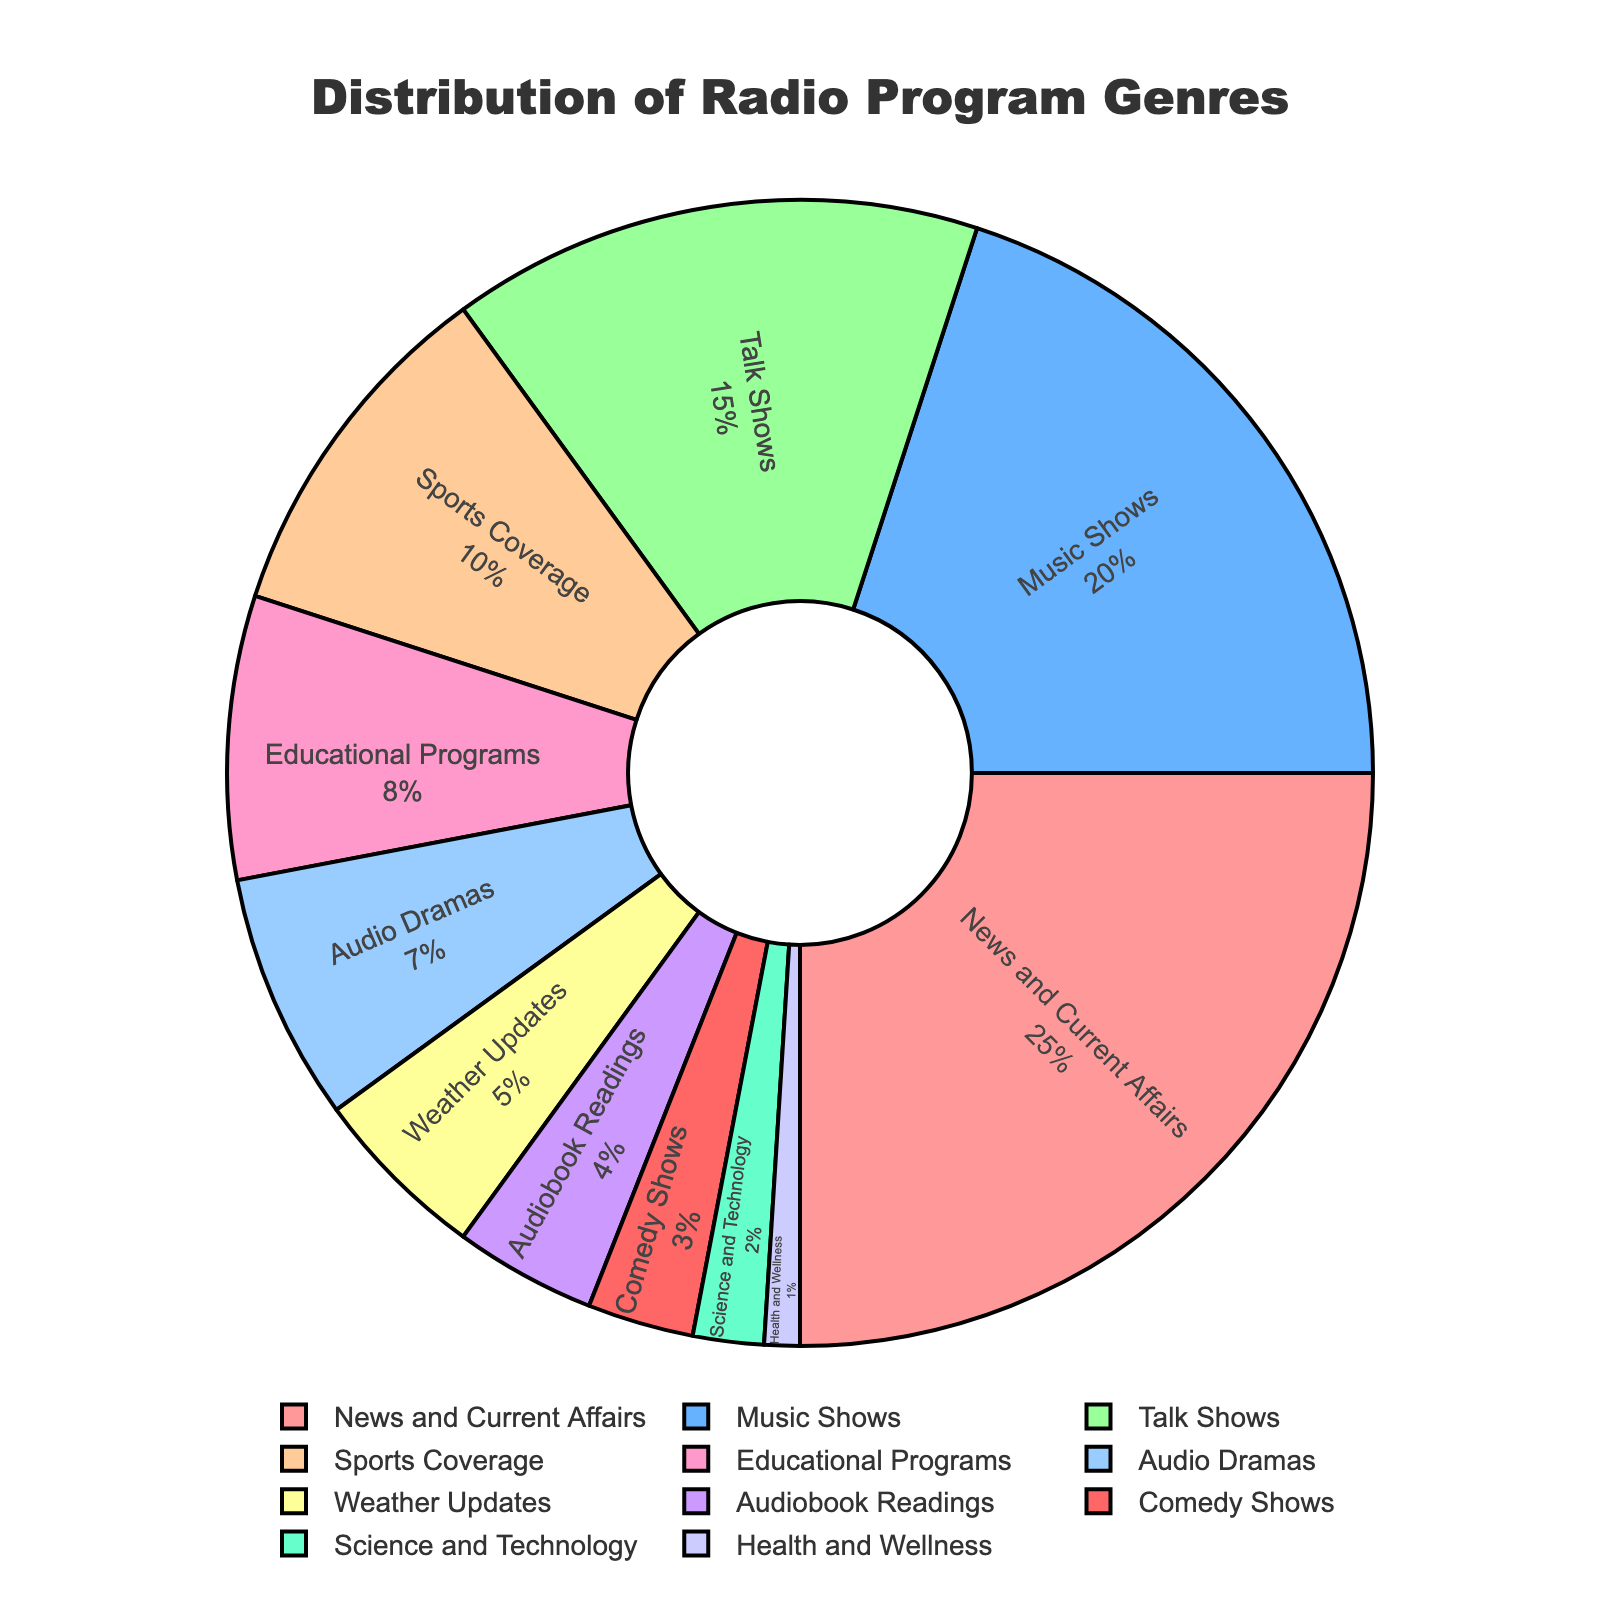What's the most represented genre in the pie chart? The genre with the highest percentage in the pie chart is the most represented. From the data, News and Current Affairs has the highest percentage at 25%.
Answer: News and Current Affairs Which genre has a larger share, Music Shows or Talk Shows? To determine which genre has a larger share, compare their percentages directly. Music Shows have 20%, while Talk Shows have 15%.
Answer: Music Shows How do the combined percentages of Weather Updates, Audiobook Readings, and Comedy Shows compare to the percentage of Music Shows? Add the percentages of Weather Updates, Audiobook Readings, and Comedy Shows: 5% + 4% + 3% = 12%. Then compare this sum to the percentage of Music Shows, which is 20%.
Answer: 12% is less than 20% What is the combined percentage of Audio Dramas and Science and Technology programs? Add the percentages of Audio Dramas and Science and Technology programs: 7% + 2% = 9%.
Answer: 9% Are Educational Programs and Sports Coverage together more than Music Shows alone? Add the percentages of Educational Programs and Sports Coverage: 8% + 10% = 18%. Then compare this sum to the percentage of Music Shows, which is 20%.
Answer: No, 18% is less than 20% Which genre occupies the least share in the pie chart? The genre with the smallest percentage occupies the least share. According to the data, Health and Wellness has the smallest percentage at 1%.
Answer: Health and Wellness How much larger is the percentage of News and Current Affairs compared to Audiobook Readings? Subtract the percentage of Audiobook Readings from News and Current Affairs: 25% - 4% = 21%.
Answer: 21% What is the difference in percentage points between Sports Coverage and Weather Updates? Subtract the percentage of Weather Updates from Sports Coverage: 10% - 5% = 5%.
Answer: 5% Out of Talk Shows, Educational Programs, and Comedy Shows, which one has the second-highest percentage? Compare the percentages of Talk Shows (15%), Educational Programs (8%), and Comedy Shows (3%). The second-highest percentage is 8% for Educational Programs.
Answer: Educational Programs Do Science and Technology programs and Health and Wellness together make up at least 5%? Add the percentages of Science and Technology and Health and Wellness: 2% + 1% = 3%. Compare this sum to 5%.
Answer: No, 3% is less than 5% 